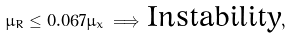<formula> <loc_0><loc_0><loc_500><loc_500>\mu _ { R } \leq 0 . 0 6 7 \mu _ { x } \, \Longrightarrow \, \text {Instability} ,</formula> 